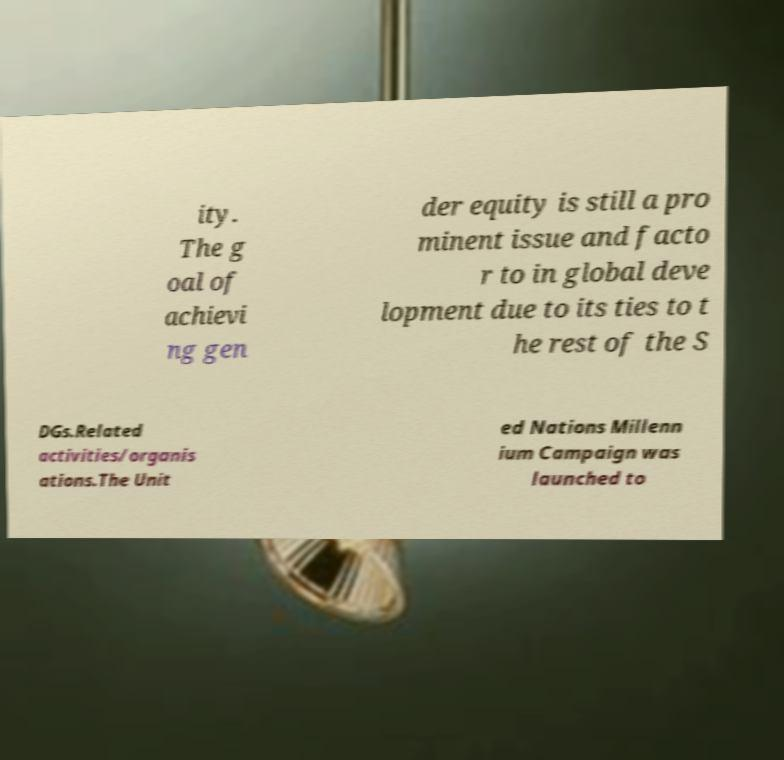There's text embedded in this image that I need extracted. Can you transcribe it verbatim? ity. The g oal of achievi ng gen der equity is still a pro minent issue and facto r to in global deve lopment due to its ties to t he rest of the S DGs.Related activities/organis ations.The Unit ed Nations Millenn ium Campaign was launched to 